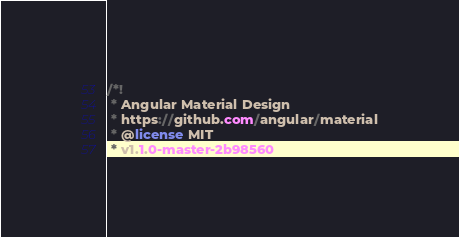Convert code to text. <code><loc_0><loc_0><loc_500><loc_500><_CSS_>/*!
 * Angular Material Design
 * https://github.com/angular/material
 * @license MIT
 * v1.1.0-master-2b98560</code> 